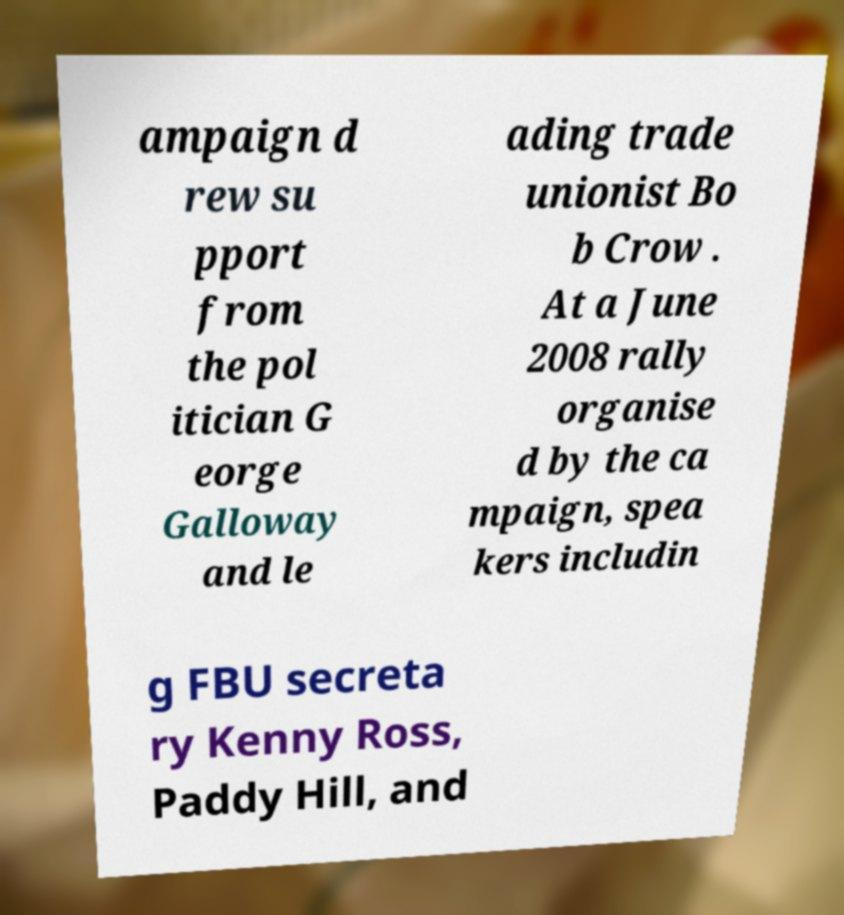For documentation purposes, I need the text within this image transcribed. Could you provide that? ampaign d rew su pport from the pol itician G eorge Galloway and le ading trade unionist Bo b Crow . At a June 2008 rally organise d by the ca mpaign, spea kers includin g FBU secreta ry Kenny Ross, Paddy Hill, and 